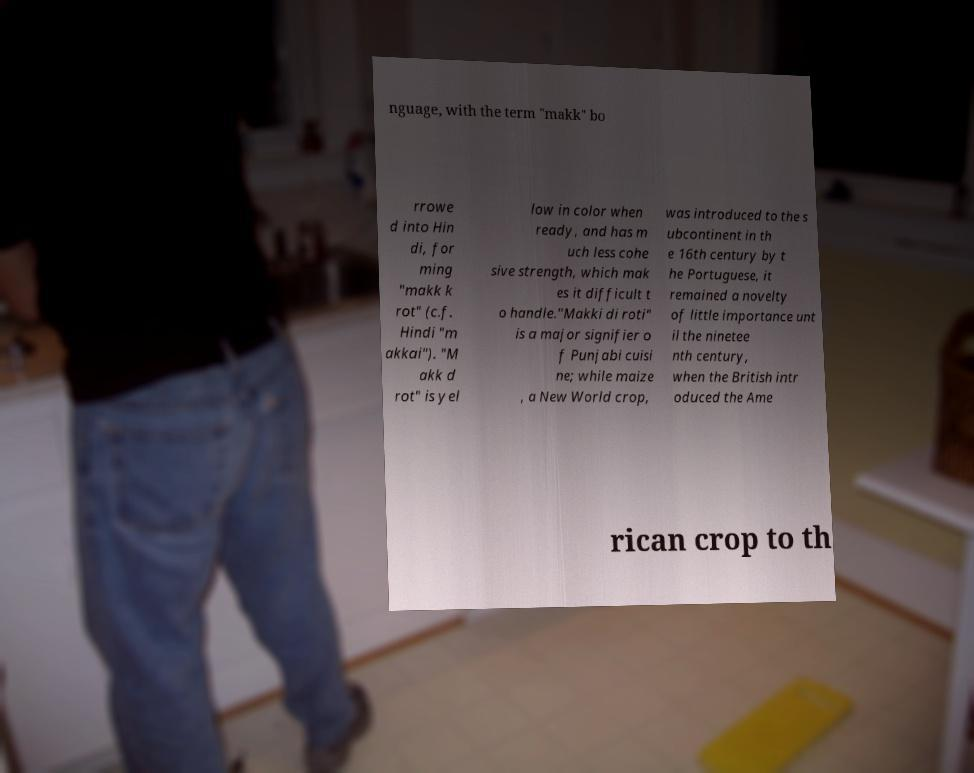Can you read and provide the text displayed in the image?This photo seems to have some interesting text. Can you extract and type it out for me? nguage, with the term "makk" bo rrowe d into Hin di, for ming "makk k rot" (c.f. Hindi "m akkai"). "M akk d rot" is yel low in color when ready, and has m uch less cohe sive strength, which mak es it difficult t o handle."Makki di roti" is a major signifier o f Punjabi cuisi ne; while maize , a New World crop, was introduced to the s ubcontinent in th e 16th century by t he Portuguese, it remained a novelty of little importance unt il the ninetee nth century, when the British intr oduced the Ame rican crop to th 